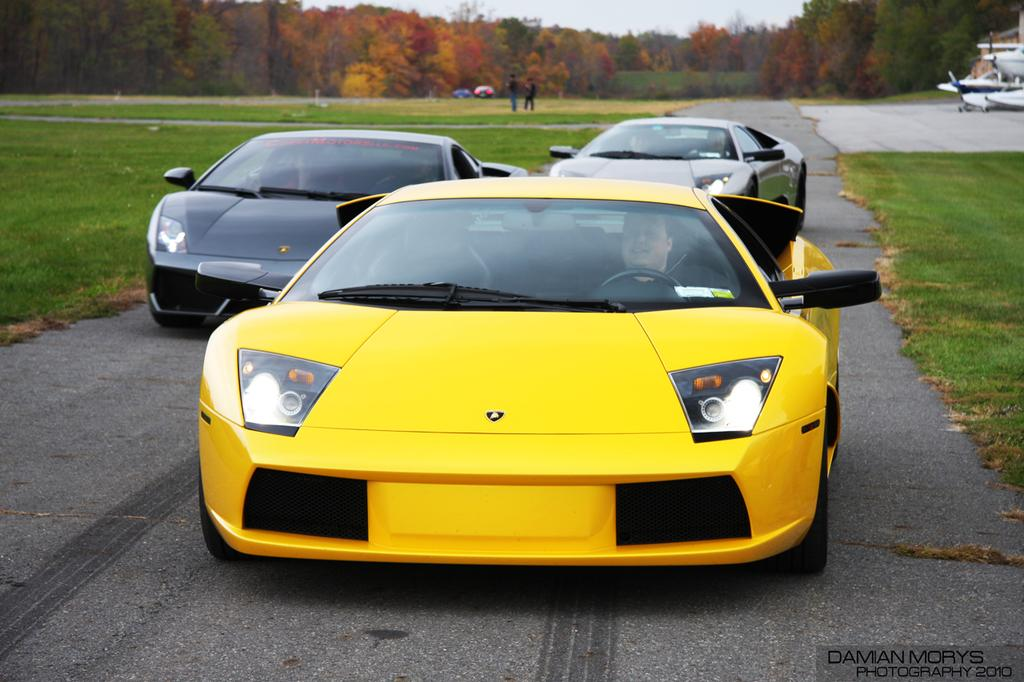What type of vehicles can be seen on the road in the image? There are cars on the road in the image. What type of natural environment is visible in the image? There is grass visible in the image, and there are trees as well. How many people are present in the image? There are two persons in the image. What else can be seen in the image besides the cars and people? There are vehicles in the image, and the sky is visible in the background. Is there a lake visible in the image? No, there is no lake present in the image. Can you see a hospital in the background of the image? No, there is no hospital visible in the image. 